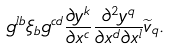<formula> <loc_0><loc_0><loc_500><loc_500>g ^ { l b } \xi _ { b } g ^ { c d } \frac { \partial y ^ { k } } { \partial x ^ { c } } \frac { \partial ^ { 2 } y ^ { q } } { \partial x ^ { d } \partial x ^ { l } } \widetilde { v } _ { q } .</formula> 